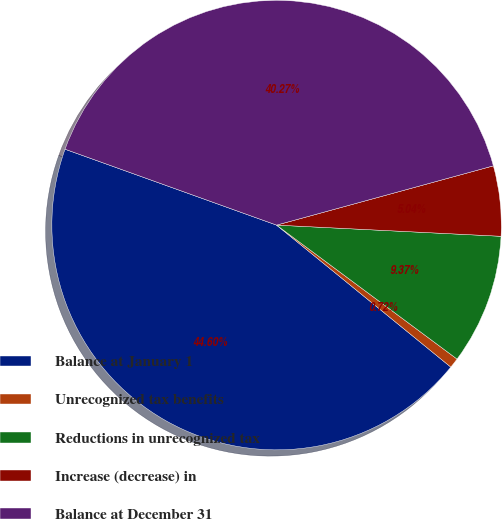Convert chart. <chart><loc_0><loc_0><loc_500><loc_500><pie_chart><fcel>Balance at January 1<fcel>Unrecognized tax benefits<fcel>Reductions in unrecognized tax<fcel>Increase (decrease) in<fcel>Balance at December 31<nl><fcel>44.6%<fcel>0.72%<fcel>9.37%<fcel>5.04%<fcel>40.27%<nl></chart> 